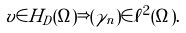<formula> <loc_0><loc_0><loc_500><loc_500>v \in H _ { D } ( \Omega ) \Rightarrow ( \gamma _ { n } ) \in \ell ^ { 2 } ( \Omega ) .</formula> 